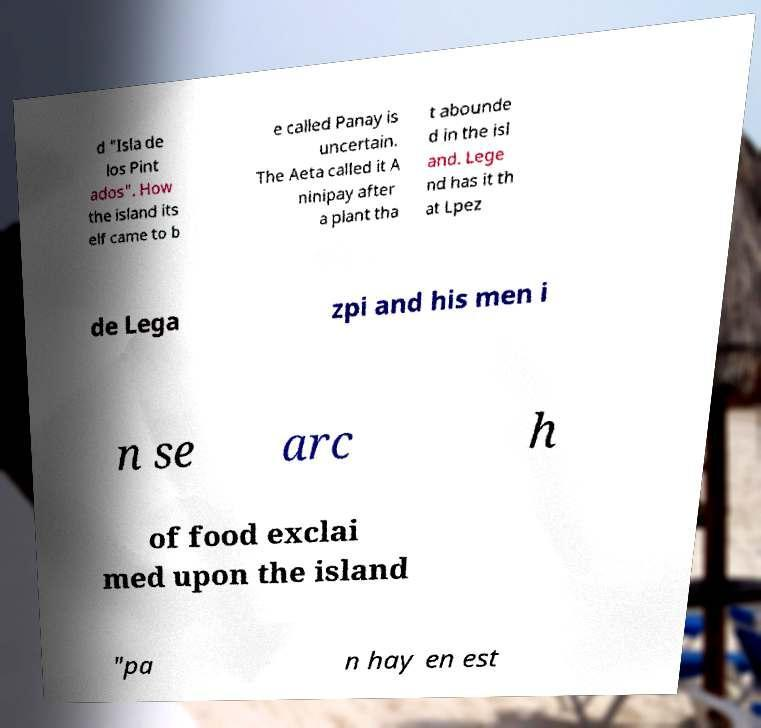Can you read and provide the text displayed in the image?This photo seems to have some interesting text. Can you extract and type it out for me? d "Isla de los Pint ados". How the island its elf came to b e called Panay is uncertain. The Aeta called it A ninipay after a plant tha t abounde d in the isl and. Lege nd has it th at Lpez de Lega zpi and his men i n se arc h of food exclai med upon the island "pa n hay en est 